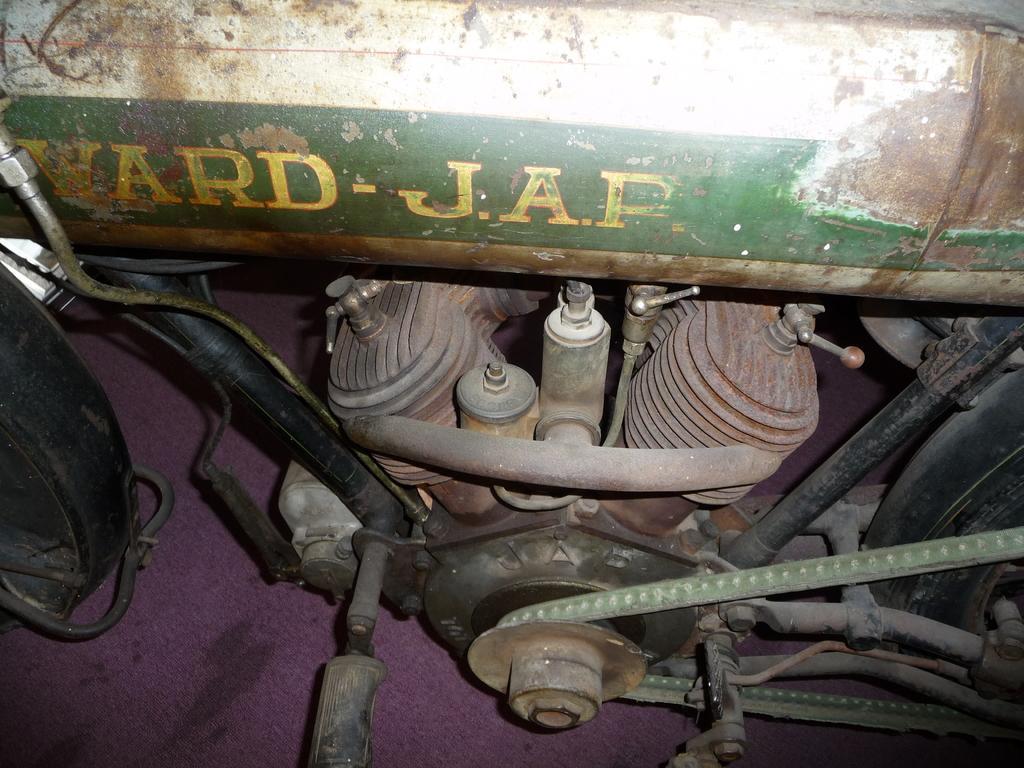In one or two sentences, can you explain what this image depicts? In this image, this looks like a vehicle. At the center of the image, I can see the engine. On the left and right sides of the image, I think these are the wheels. 